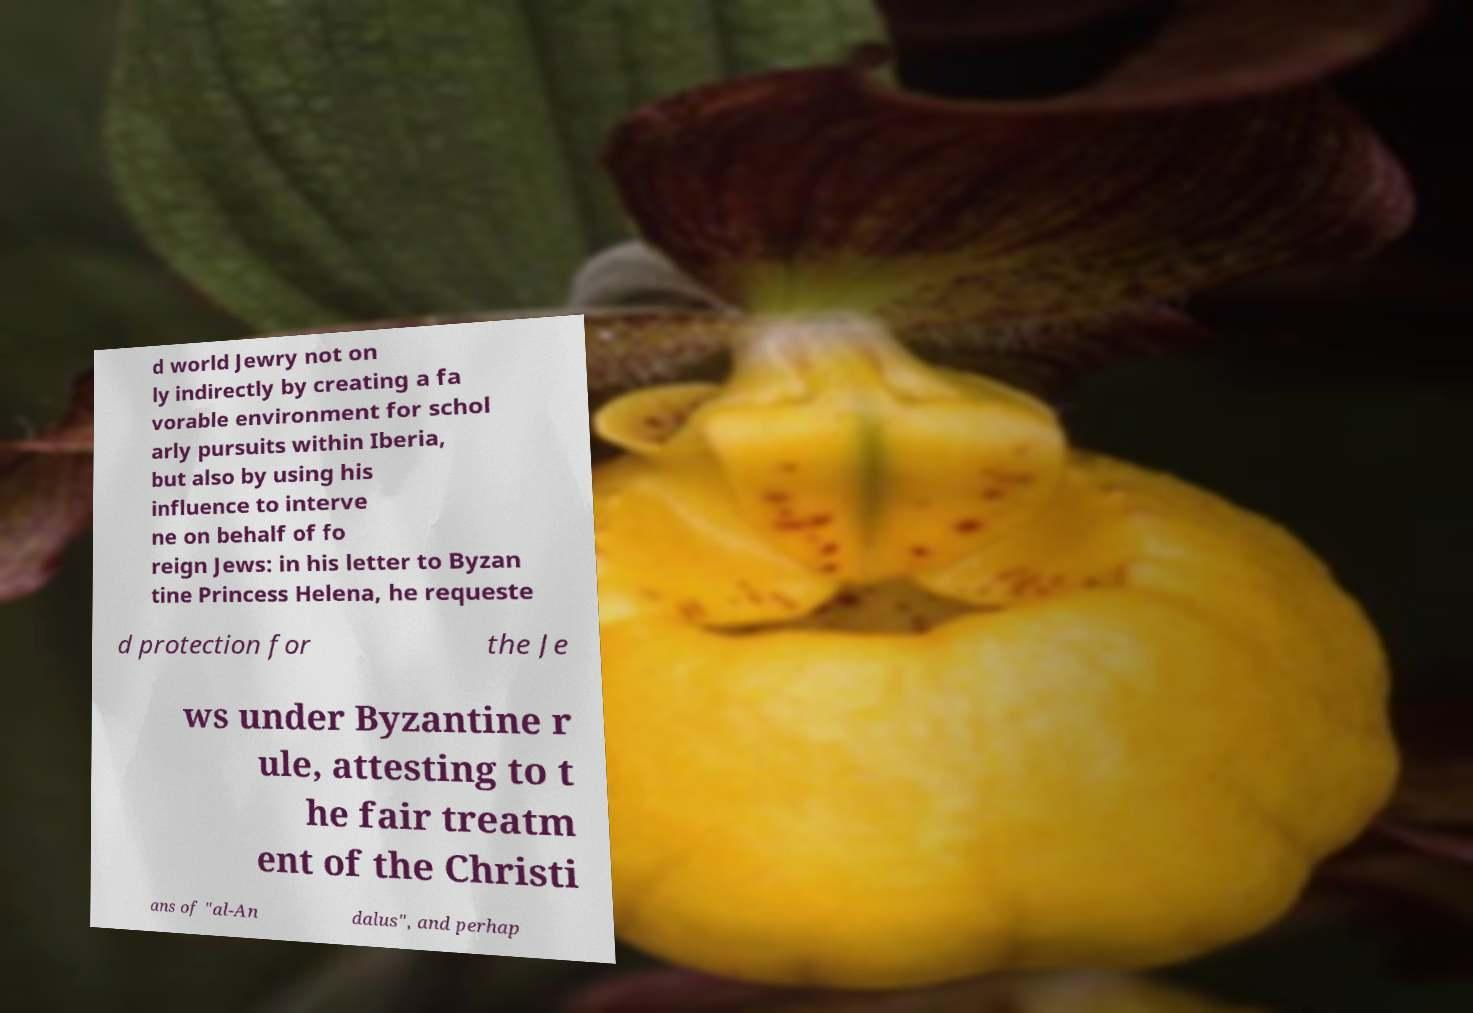Can you read and provide the text displayed in the image?This photo seems to have some interesting text. Can you extract and type it out for me? d world Jewry not on ly indirectly by creating a fa vorable environment for schol arly pursuits within Iberia, but also by using his influence to interve ne on behalf of fo reign Jews: in his letter to Byzan tine Princess Helena, he requeste d protection for the Je ws under Byzantine r ule, attesting to t he fair treatm ent of the Christi ans of "al-An dalus", and perhap 